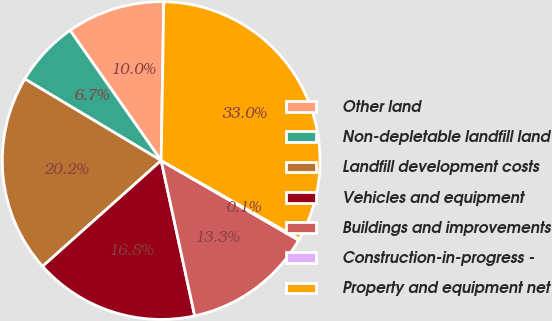<chart> <loc_0><loc_0><loc_500><loc_500><pie_chart><fcel>Other land<fcel>Non-depletable landfill land<fcel>Landfill development costs<fcel>Vehicles and equipment<fcel>Buildings and improvements<fcel>Construction-in-progress -<fcel>Property and equipment net<nl><fcel>9.98%<fcel>6.7%<fcel>20.18%<fcel>16.79%<fcel>13.26%<fcel>0.13%<fcel>32.96%<nl></chart> 